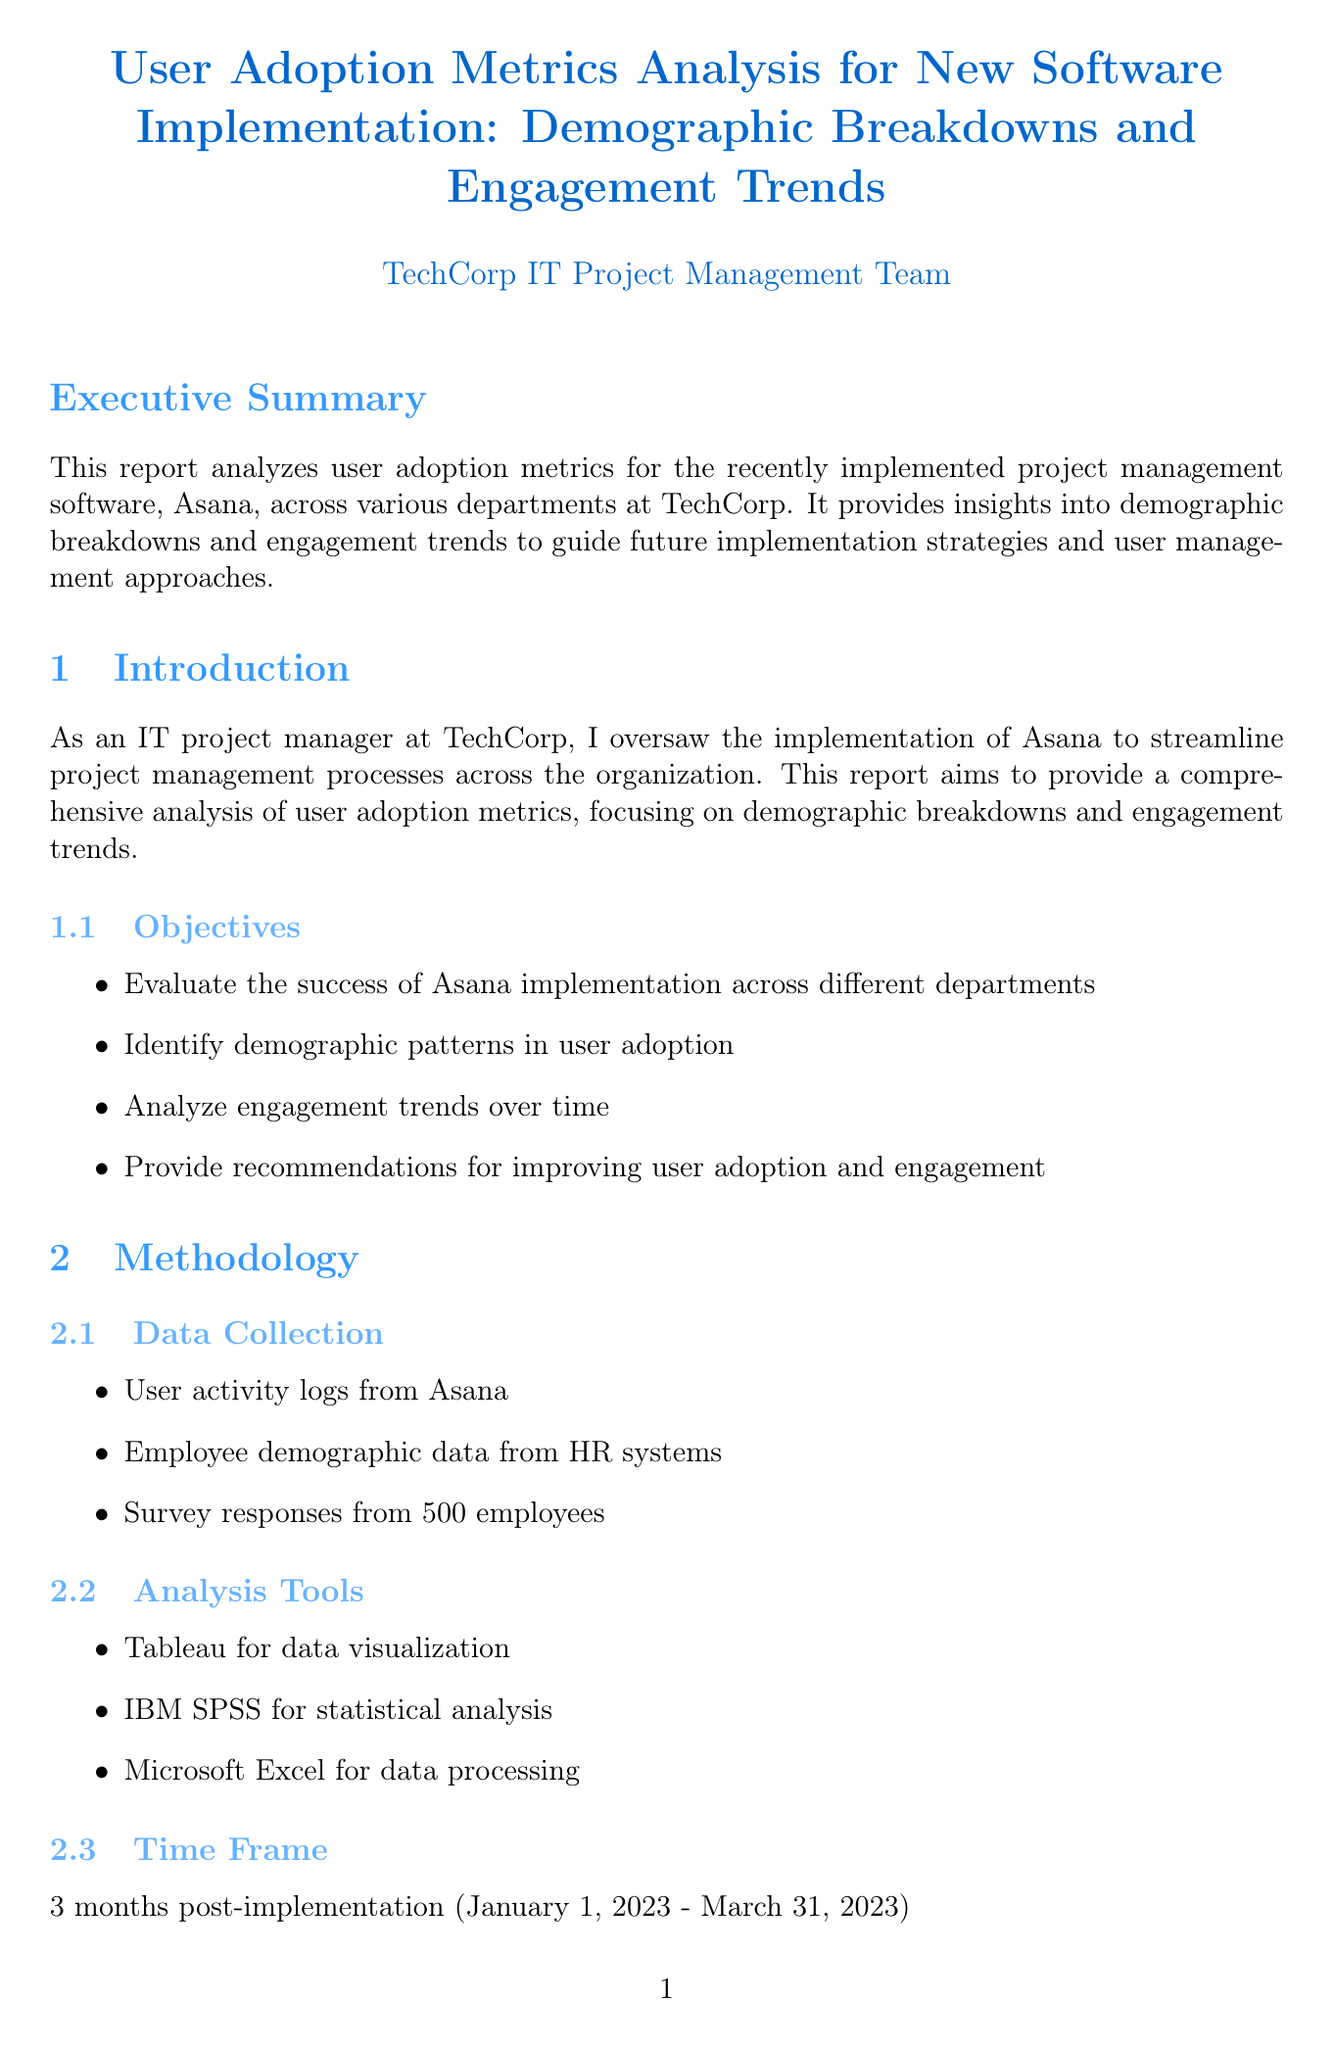What was the adoption rate for the 26-35 age group? The adoption rate for the 26-35 age group is specifically mentioned in the demographic breakdown section of the report.
Answer: 72% Which department had the lowest adoption rate? The department with the lowest adoption rate is explicitly stated in the table under the departments breakdown.
Answer: Sales What percentage of users were retained after 60 days? The 60-day retention rate is provided in the user retention section, detailing the user retention statistics over time.
Answer: 79% How many daily active users were recorded in week 12? The number of daily active users in week 12 is reported under the daily active users section of engagement trends.
Answer: 680 What is one key insight regarding the 46+ age group adoption rate? The key insight highlights a need for a specific improvement for the 46+ age group as mentioned in the demographic breakdown.
Answer: Requires targeted training Which feature had the highest usage rate across all departments? The feature with the highest usage rate is stated in the feature usage section, detailing how different features were utilized.
Answer: Task Creation What increase percentage was reported in daily active users over the 3-month period? This percentage is summarized in the key findings section, indicating a significant change over the observed period.
Answer: 172% What was one of the recommendations made in the report? The recommendations section outlines several strategies to improve user adoption and engagement, providing direct suggestions.
Answer: Develop targeted training programs for employees aged 46+ 